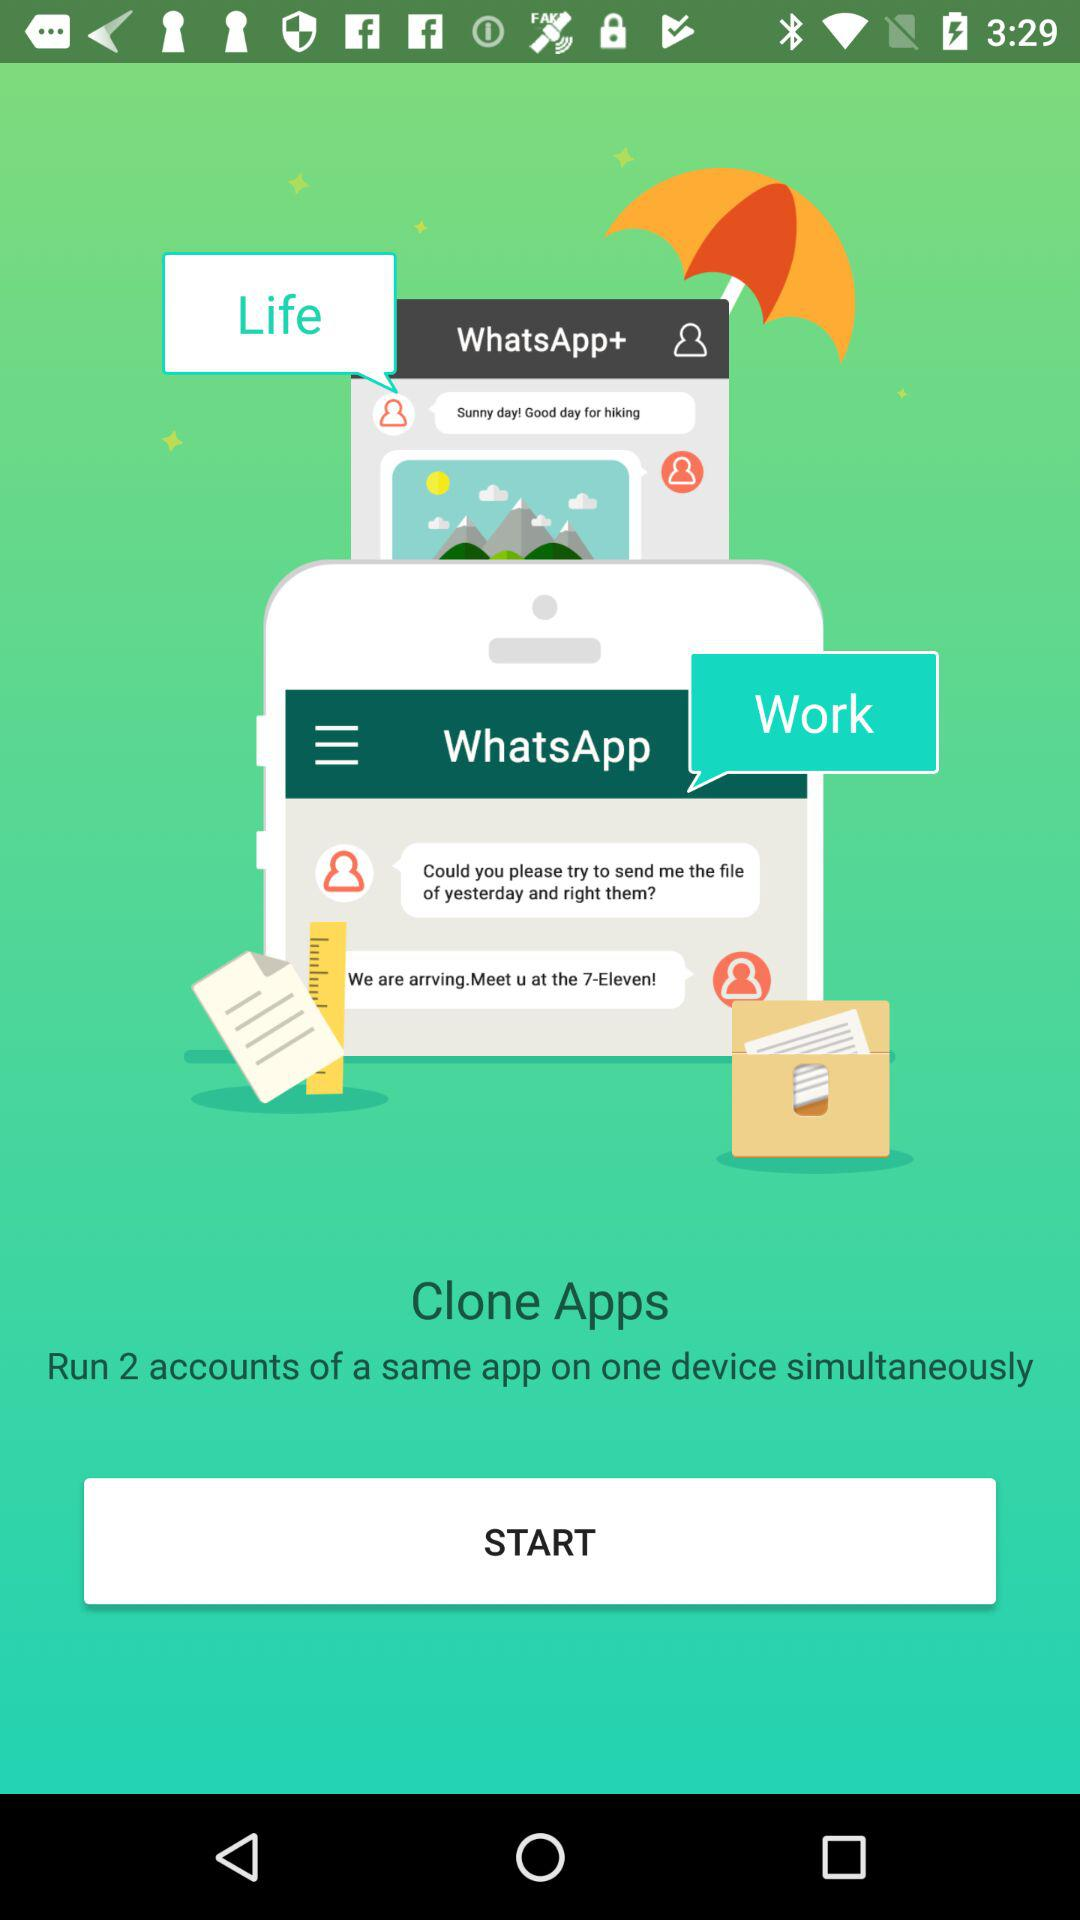How many accounts can we run on the same app on one device simultaneously? You can run 2 accounts on the same app on one device simultaneously. 